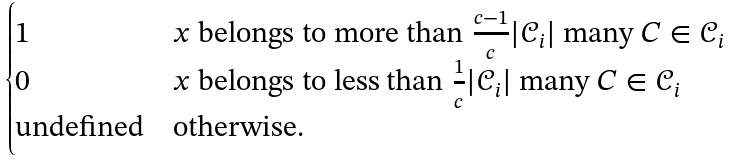<formula> <loc_0><loc_0><loc_500><loc_500>\begin{cases} 1 & x \text { belongs to more than } \frac { c - 1 } { c } | \mathcal { C } _ { i } | \text { many } C \in \mathcal { C } _ { i } \\ 0 & x \text { belongs to less than } \frac { 1 } { c } | \mathcal { C } _ { i } | \text { many } C \in \mathcal { C } _ { i } \\ \text {undefined} & \text {otherwise.} \end{cases}</formula> 